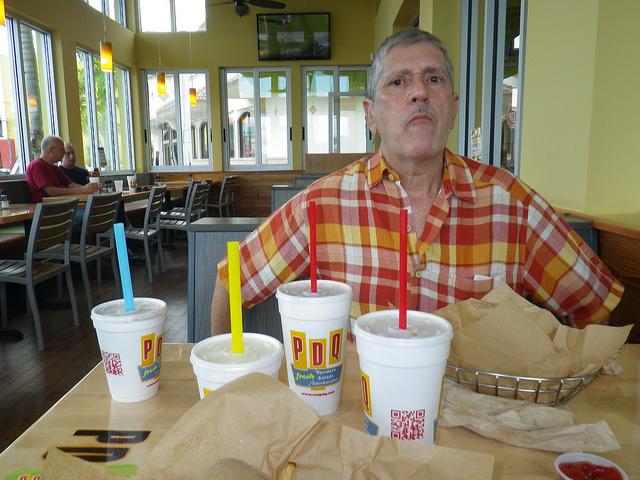Is the man wearing a colorful shirt?
Be succinct. Yes. What is the business called that this picture was taken in?
Concise answer only. Pdq. What is the man looking at?
Answer briefly. Camera. How many people are there?
Give a very brief answer. 3. Does the man appear hungry?
Quick response, please. No. 